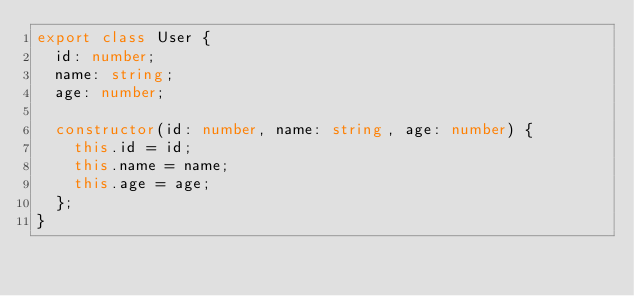Convert code to text. <code><loc_0><loc_0><loc_500><loc_500><_TypeScript_>export class User {
  id: number;
  name: string;
  age: number;

  constructor(id: number, name: string, age: number) {
    this.id = id;
    this.name = name;
    this.age = age;
  };
}
</code> 